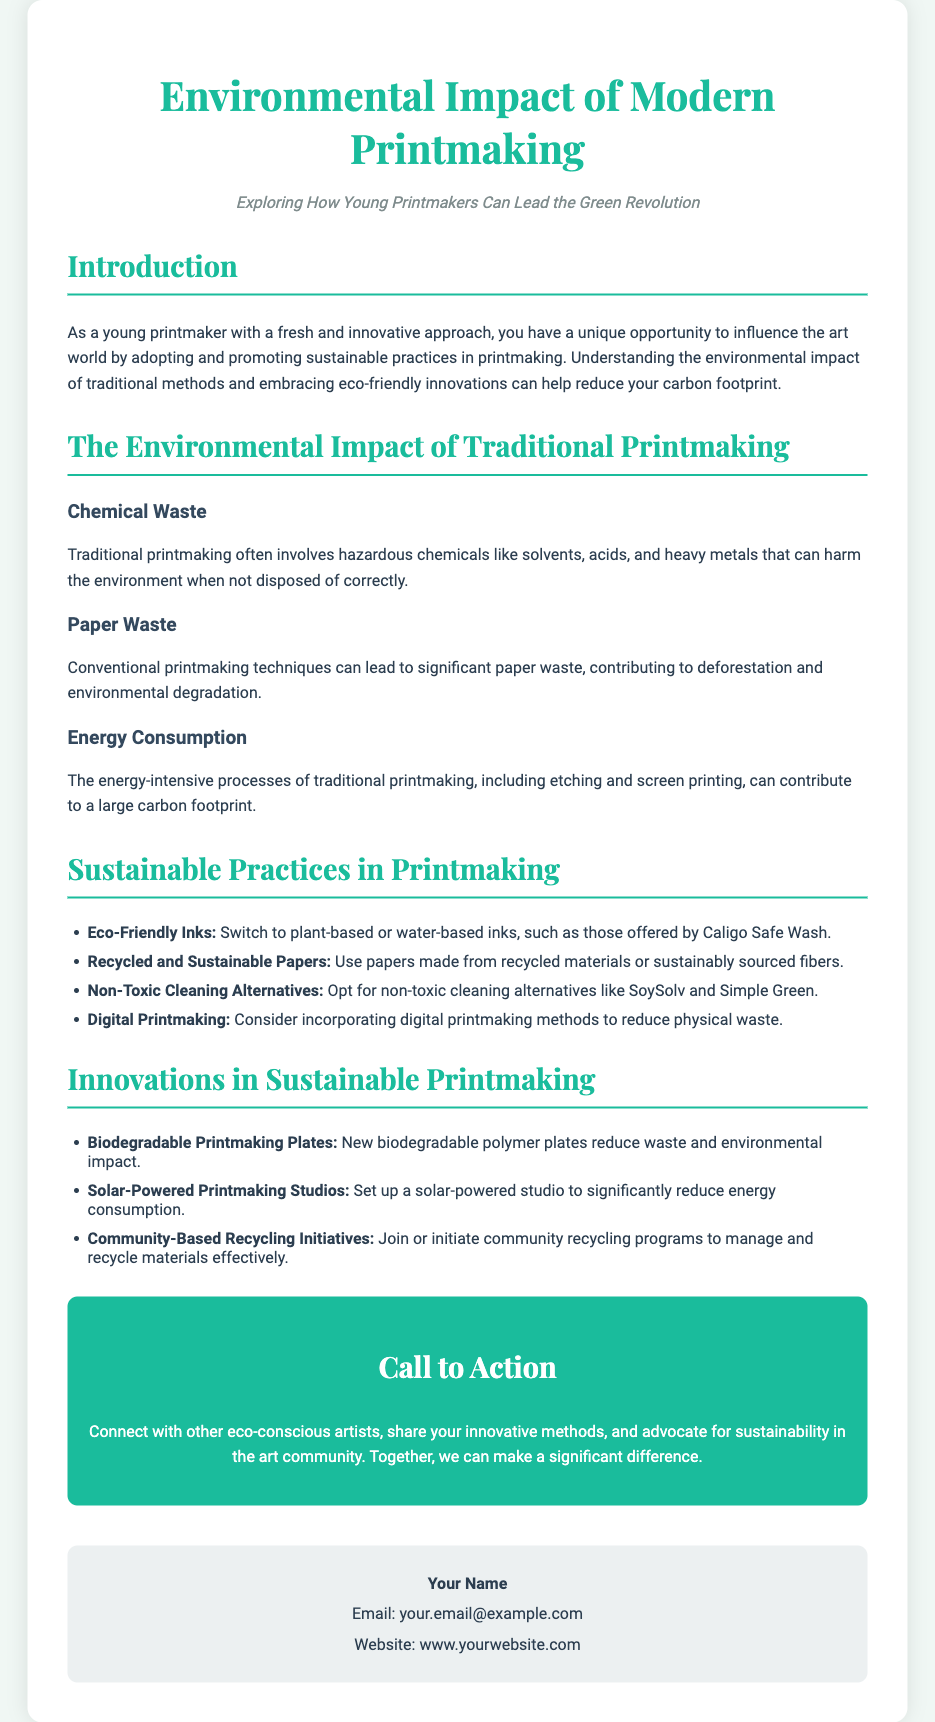What is the title of the flyer? The title of the flyer is displayed prominently at the top of the document.
Answer: Environmental Impact of Modern Printmaking Who is the target audience mentioned in the flyer? The flyer mentions young printmakers as the primary audience who can influence eco-friendly practices.
Answer: Young printmakers What chemical waste is often involved in traditional printmaking? This phrase refers to hazardous substances that can harm the environment during traditional printmaking.
Answer: Hazardous chemicals What type of inks are recommended for sustainable practices? This refers to the types of inks that are eco-friendly as mentioned in the sustainable practices section.
Answer: Plant-based or water-based inks What is a suggested alternative to traditional cleaning methods? This asks about non-toxic cleaning options mentioned in the document that reduce environmental impact.
Answer: Non-toxic cleaning alternatives What innovation helps reduce waste in printmaking? This prompts for a specific type of innovation that minimizes the environmental impact in printmaking.
Answer: Biodegradable printmaking plates What kind of printmaking is suggested to reduce physical waste? This specifically asks about the type of printmaking method encouraged for sustainability.
Answer: Digital printmaking What is the call to action encouraging artists to do? The call to action section contains suggestions for community engagement and individual actions.
Answer: Connect with other eco-conscious artists What color scheme is used for the flyer title? This question pertains to the visual design choices made in the document.
Answer: Teal 